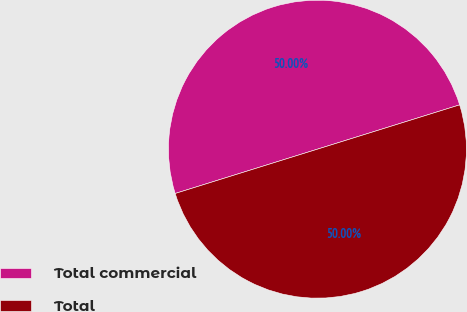Convert chart to OTSL. <chart><loc_0><loc_0><loc_500><loc_500><pie_chart><fcel>Total commercial<fcel>Total<nl><fcel>50.0%<fcel>50.0%<nl></chart> 